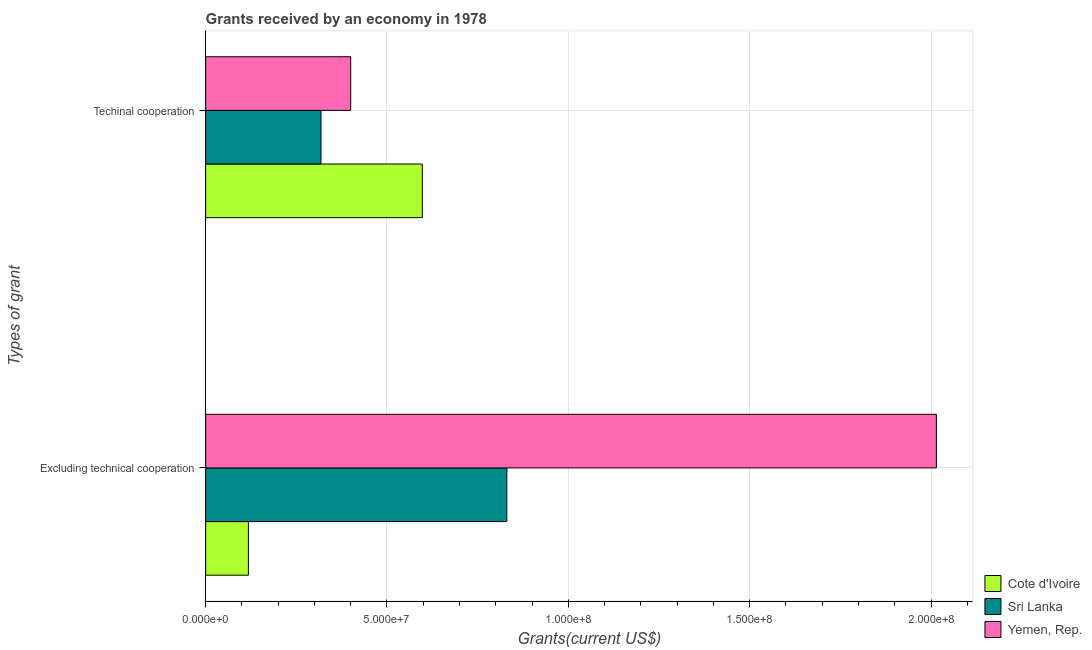Are the number of bars on each tick of the Y-axis equal?
Give a very brief answer. Yes. How many bars are there on the 1st tick from the top?
Give a very brief answer. 3. How many bars are there on the 1st tick from the bottom?
Your answer should be compact. 3. What is the label of the 1st group of bars from the top?
Make the answer very short. Techinal cooperation. What is the amount of grants received(excluding technical cooperation) in Cote d'Ivoire?
Offer a very short reply. 1.18e+07. Across all countries, what is the maximum amount of grants received(including technical cooperation)?
Offer a terse response. 5.97e+07. Across all countries, what is the minimum amount of grants received(including technical cooperation)?
Offer a very short reply. 3.18e+07. In which country was the amount of grants received(excluding technical cooperation) maximum?
Your response must be concise. Yemen, Rep. In which country was the amount of grants received(excluding technical cooperation) minimum?
Your response must be concise. Cote d'Ivoire. What is the total amount of grants received(including technical cooperation) in the graph?
Ensure brevity in your answer.  1.32e+08. What is the difference between the amount of grants received(excluding technical cooperation) in Yemen, Rep. and that in Sri Lanka?
Give a very brief answer. 1.18e+08. What is the difference between the amount of grants received(including technical cooperation) in Yemen, Rep. and the amount of grants received(excluding technical cooperation) in Cote d'Ivoire?
Your answer should be very brief. 2.82e+07. What is the average amount of grants received(excluding technical cooperation) per country?
Your answer should be compact. 9.88e+07. What is the difference between the amount of grants received(excluding technical cooperation) and amount of grants received(including technical cooperation) in Yemen, Rep.?
Ensure brevity in your answer.  1.61e+08. What is the ratio of the amount of grants received(excluding technical cooperation) in Sri Lanka to that in Cote d'Ivoire?
Provide a short and direct response. 7.04. Is the amount of grants received(excluding technical cooperation) in Sri Lanka less than that in Yemen, Rep.?
Your answer should be compact. Yes. What does the 3rd bar from the top in Excluding technical cooperation represents?
Provide a short and direct response. Cote d'Ivoire. What does the 2nd bar from the bottom in Techinal cooperation represents?
Ensure brevity in your answer.  Sri Lanka. How many bars are there?
Provide a short and direct response. 6. Are all the bars in the graph horizontal?
Ensure brevity in your answer.  Yes. How many countries are there in the graph?
Your response must be concise. 3. How many legend labels are there?
Your answer should be very brief. 3. What is the title of the graph?
Offer a terse response. Grants received by an economy in 1978. What is the label or title of the X-axis?
Your response must be concise. Grants(current US$). What is the label or title of the Y-axis?
Keep it short and to the point. Types of grant. What is the Grants(current US$) of Cote d'Ivoire in Excluding technical cooperation?
Ensure brevity in your answer.  1.18e+07. What is the Grants(current US$) in Sri Lanka in Excluding technical cooperation?
Offer a terse response. 8.30e+07. What is the Grants(current US$) in Yemen, Rep. in Excluding technical cooperation?
Give a very brief answer. 2.01e+08. What is the Grants(current US$) in Cote d'Ivoire in Techinal cooperation?
Make the answer very short. 5.97e+07. What is the Grants(current US$) in Sri Lanka in Techinal cooperation?
Give a very brief answer. 3.18e+07. What is the Grants(current US$) of Yemen, Rep. in Techinal cooperation?
Your answer should be very brief. 4.00e+07. Across all Types of grant, what is the maximum Grants(current US$) of Cote d'Ivoire?
Your answer should be compact. 5.97e+07. Across all Types of grant, what is the maximum Grants(current US$) in Sri Lanka?
Provide a short and direct response. 8.30e+07. Across all Types of grant, what is the maximum Grants(current US$) of Yemen, Rep.?
Your answer should be very brief. 2.01e+08. Across all Types of grant, what is the minimum Grants(current US$) of Cote d'Ivoire?
Provide a short and direct response. 1.18e+07. Across all Types of grant, what is the minimum Grants(current US$) in Sri Lanka?
Ensure brevity in your answer.  3.18e+07. Across all Types of grant, what is the minimum Grants(current US$) of Yemen, Rep.?
Keep it short and to the point. 4.00e+07. What is the total Grants(current US$) in Cote d'Ivoire in the graph?
Your response must be concise. 7.15e+07. What is the total Grants(current US$) of Sri Lanka in the graph?
Your answer should be very brief. 1.15e+08. What is the total Grants(current US$) of Yemen, Rep. in the graph?
Offer a very short reply. 2.41e+08. What is the difference between the Grants(current US$) of Cote d'Ivoire in Excluding technical cooperation and that in Techinal cooperation?
Offer a terse response. -4.80e+07. What is the difference between the Grants(current US$) in Sri Lanka in Excluding technical cooperation and that in Techinal cooperation?
Your answer should be very brief. 5.12e+07. What is the difference between the Grants(current US$) of Yemen, Rep. in Excluding technical cooperation and that in Techinal cooperation?
Your response must be concise. 1.61e+08. What is the difference between the Grants(current US$) of Cote d'Ivoire in Excluding technical cooperation and the Grants(current US$) of Sri Lanka in Techinal cooperation?
Your response must be concise. -2.00e+07. What is the difference between the Grants(current US$) in Cote d'Ivoire in Excluding technical cooperation and the Grants(current US$) in Yemen, Rep. in Techinal cooperation?
Your answer should be compact. -2.82e+07. What is the difference between the Grants(current US$) in Sri Lanka in Excluding technical cooperation and the Grants(current US$) in Yemen, Rep. in Techinal cooperation?
Provide a short and direct response. 4.30e+07. What is the average Grants(current US$) of Cote d'Ivoire per Types of grant?
Offer a very short reply. 3.58e+07. What is the average Grants(current US$) of Sri Lanka per Types of grant?
Your answer should be very brief. 5.74e+07. What is the average Grants(current US$) of Yemen, Rep. per Types of grant?
Ensure brevity in your answer.  1.21e+08. What is the difference between the Grants(current US$) in Cote d'Ivoire and Grants(current US$) in Sri Lanka in Excluding technical cooperation?
Offer a terse response. -7.13e+07. What is the difference between the Grants(current US$) in Cote d'Ivoire and Grants(current US$) in Yemen, Rep. in Excluding technical cooperation?
Offer a terse response. -1.90e+08. What is the difference between the Grants(current US$) in Sri Lanka and Grants(current US$) in Yemen, Rep. in Excluding technical cooperation?
Keep it short and to the point. -1.18e+08. What is the difference between the Grants(current US$) in Cote d'Ivoire and Grants(current US$) in Sri Lanka in Techinal cooperation?
Your response must be concise. 2.79e+07. What is the difference between the Grants(current US$) of Cote d'Ivoire and Grants(current US$) of Yemen, Rep. in Techinal cooperation?
Provide a succinct answer. 1.97e+07. What is the difference between the Grants(current US$) of Sri Lanka and Grants(current US$) of Yemen, Rep. in Techinal cooperation?
Offer a very short reply. -8.19e+06. What is the ratio of the Grants(current US$) in Cote d'Ivoire in Excluding technical cooperation to that in Techinal cooperation?
Keep it short and to the point. 0.2. What is the ratio of the Grants(current US$) in Sri Lanka in Excluding technical cooperation to that in Techinal cooperation?
Give a very brief answer. 2.61. What is the ratio of the Grants(current US$) in Yemen, Rep. in Excluding technical cooperation to that in Techinal cooperation?
Offer a very short reply. 5.04. What is the difference between the highest and the second highest Grants(current US$) in Cote d'Ivoire?
Your answer should be compact. 4.80e+07. What is the difference between the highest and the second highest Grants(current US$) in Sri Lanka?
Offer a terse response. 5.12e+07. What is the difference between the highest and the second highest Grants(current US$) in Yemen, Rep.?
Keep it short and to the point. 1.61e+08. What is the difference between the highest and the lowest Grants(current US$) of Cote d'Ivoire?
Make the answer very short. 4.80e+07. What is the difference between the highest and the lowest Grants(current US$) in Sri Lanka?
Your response must be concise. 5.12e+07. What is the difference between the highest and the lowest Grants(current US$) in Yemen, Rep.?
Your answer should be very brief. 1.61e+08. 